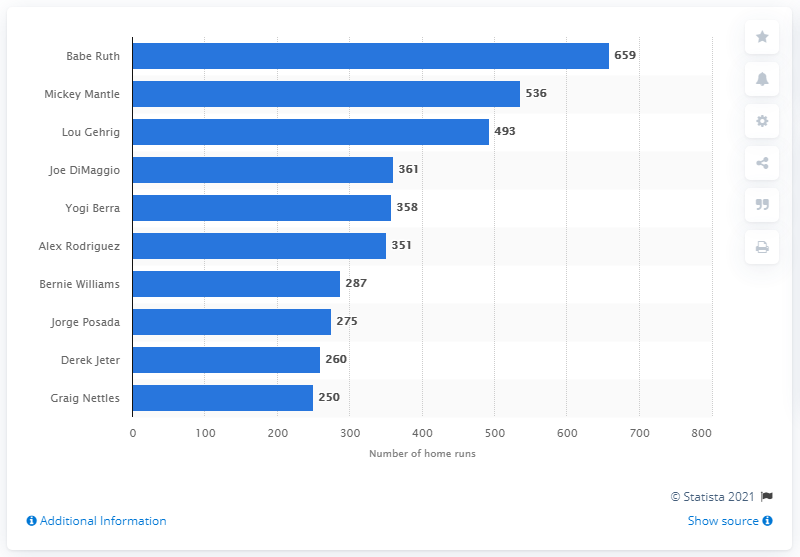Give some essential details in this illustration. The total number of home runs hit by Babe Ruth is 659. Babe Ruth is the player who has hit the most home runs in the history of the New York Yankees franchise. 